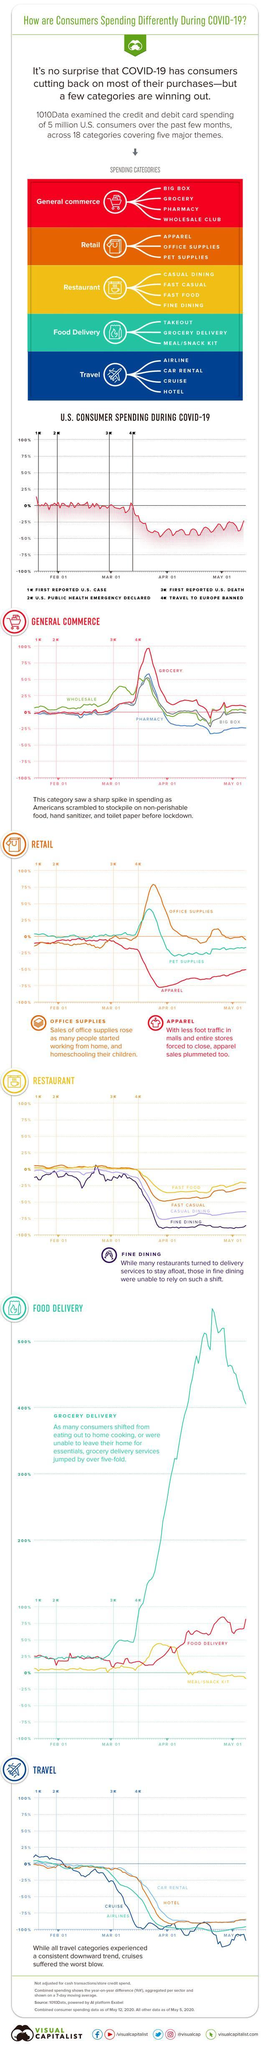When was the US public health emergency declared - January 31, February 1, March 01, April 01?
Answer the question with a short phrase. January 31 